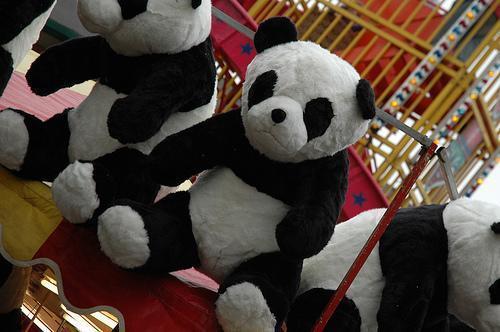How many bears are there?
Give a very brief answer. 3. 